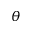<formula> <loc_0><loc_0><loc_500><loc_500>\theta</formula> 